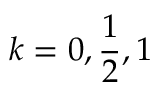<formula> <loc_0><loc_0><loc_500><loc_500>k = 0 , \frac { 1 } { 2 } , 1</formula> 